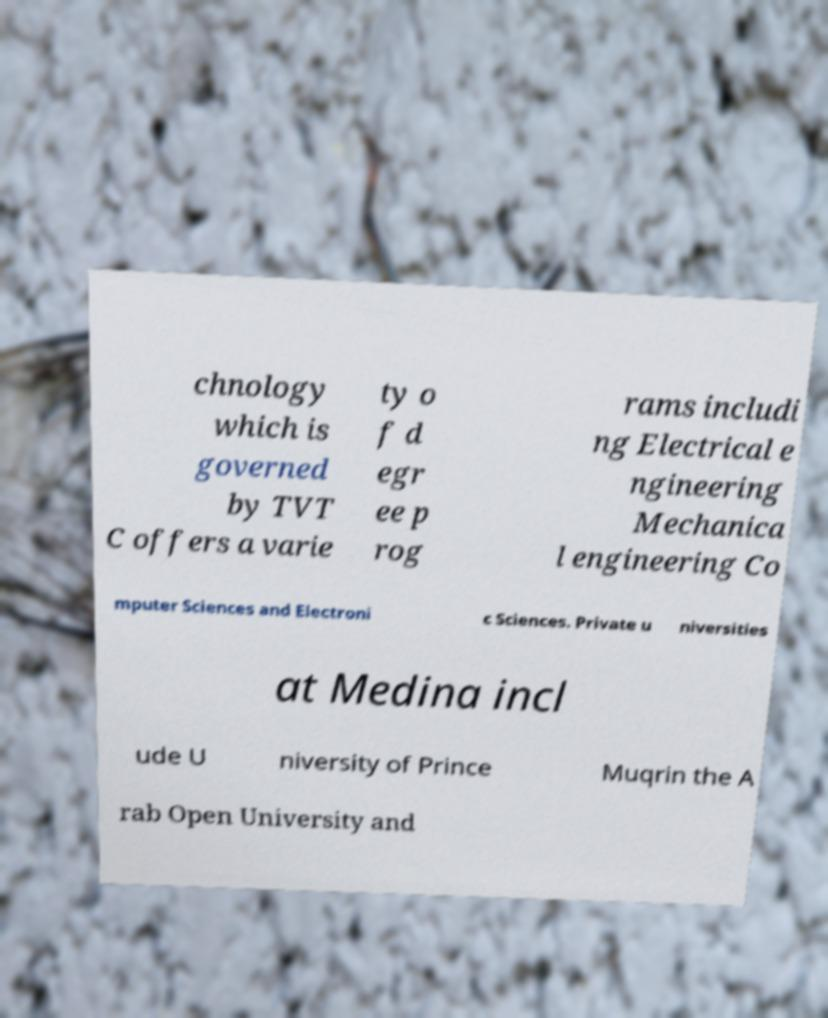Can you accurately transcribe the text from the provided image for me? chnology which is governed by TVT C offers a varie ty o f d egr ee p rog rams includi ng Electrical e ngineering Mechanica l engineering Co mputer Sciences and Electroni c Sciences. Private u niversities at Medina incl ude U niversity of Prince Muqrin the A rab Open University and 